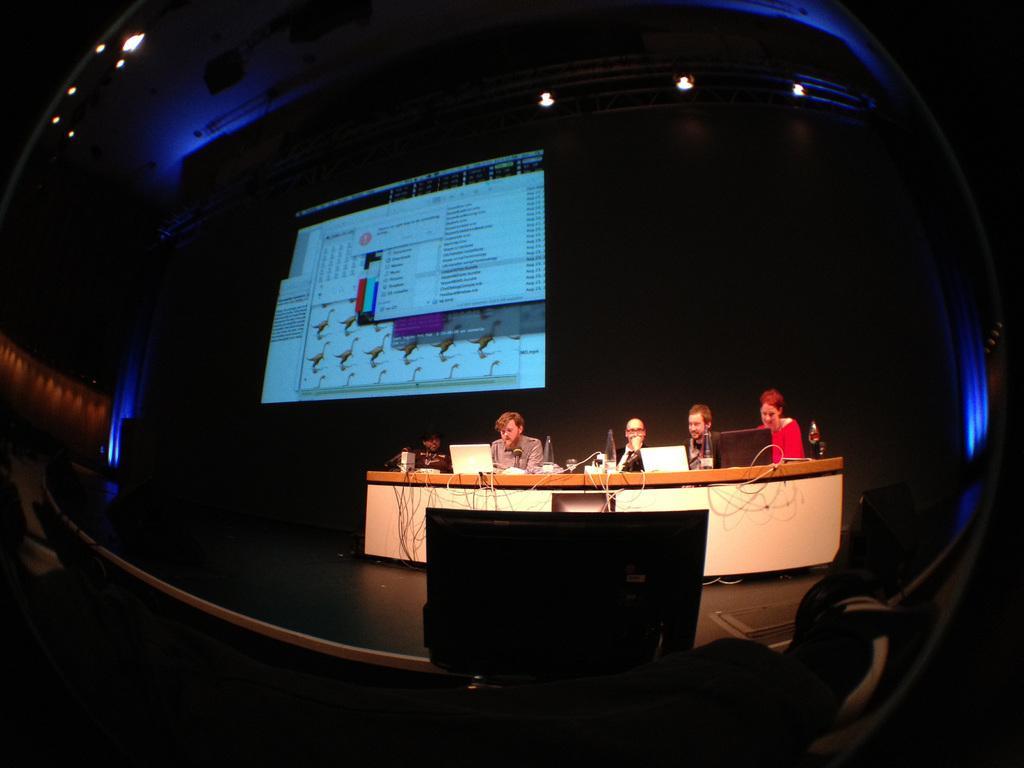Could you give a brief overview of what you see in this image? In the image we can see there are people sitting on the chair and there are laptops kept on the table. There are wires connected to the laptop and behind there is a projector screen on the wall. 